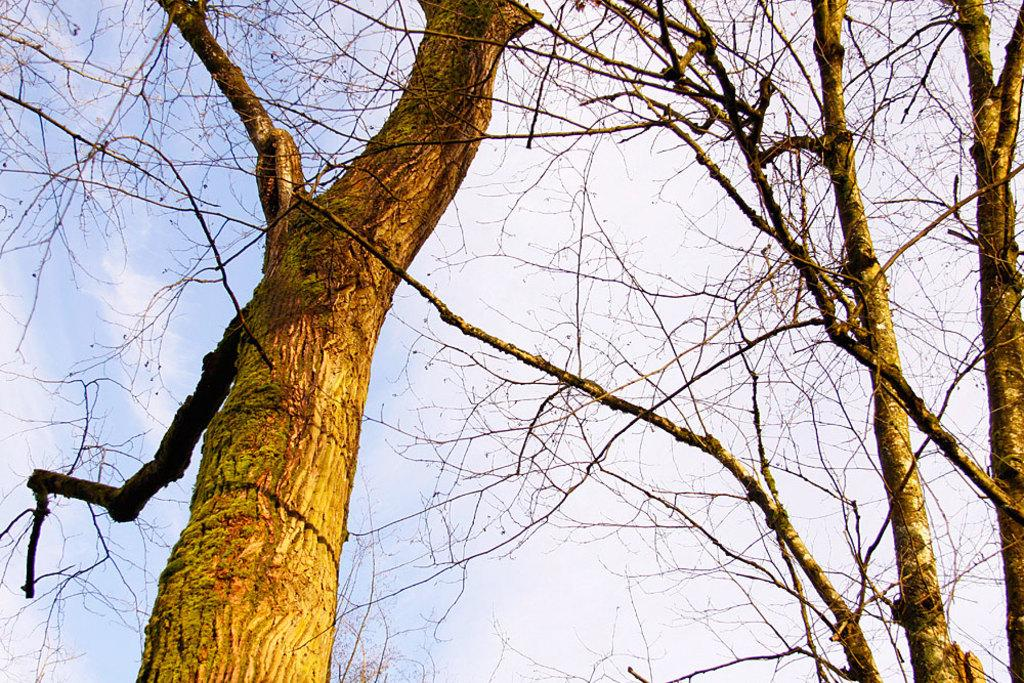What is the main subject of the picture? The main subject of the picture is a tree. What specific features can be observed on the tree? The tree has branches and twigs. What is the condition of the sky in the picture? The sky is clear in the picture. Can you tell me how many clouds are visible around the tree in the image? There are no clouds visible in the image; the sky is clear. What type of substance is the girl holding in the image? There is no girl present in the image; it features a tree with branches and twigs. 